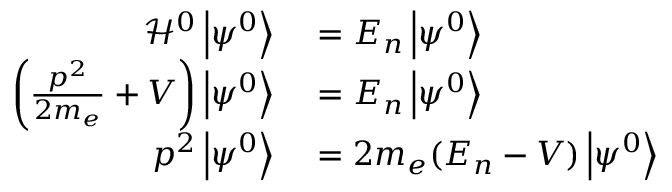<formula> <loc_0><loc_0><loc_500><loc_500>\begin{array} { r l } { { \mathcal { H } } ^ { 0 } \left | \psi ^ { 0 } \right \rangle } & = E _ { n } \left | \psi ^ { 0 } \right \rangle } \\ { \left ( { \frac { p ^ { 2 } } { 2 m _ { e } } } + V \right ) \left | \psi ^ { 0 } \right \rangle } & = E _ { n } \left | \psi ^ { 0 } \right \rangle } \\ { p ^ { 2 } \left | \psi ^ { 0 } \right \rangle } & = 2 m _ { e } ( E _ { n } - V ) \left | \psi ^ { 0 } \right \rangle } \end{array}</formula> 